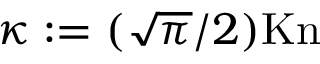<formula> <loc_0><loc_0><loc_500><loc_500>\kappa \colon = ( \sqrt { \pi } / 2 ) K n</formula> 